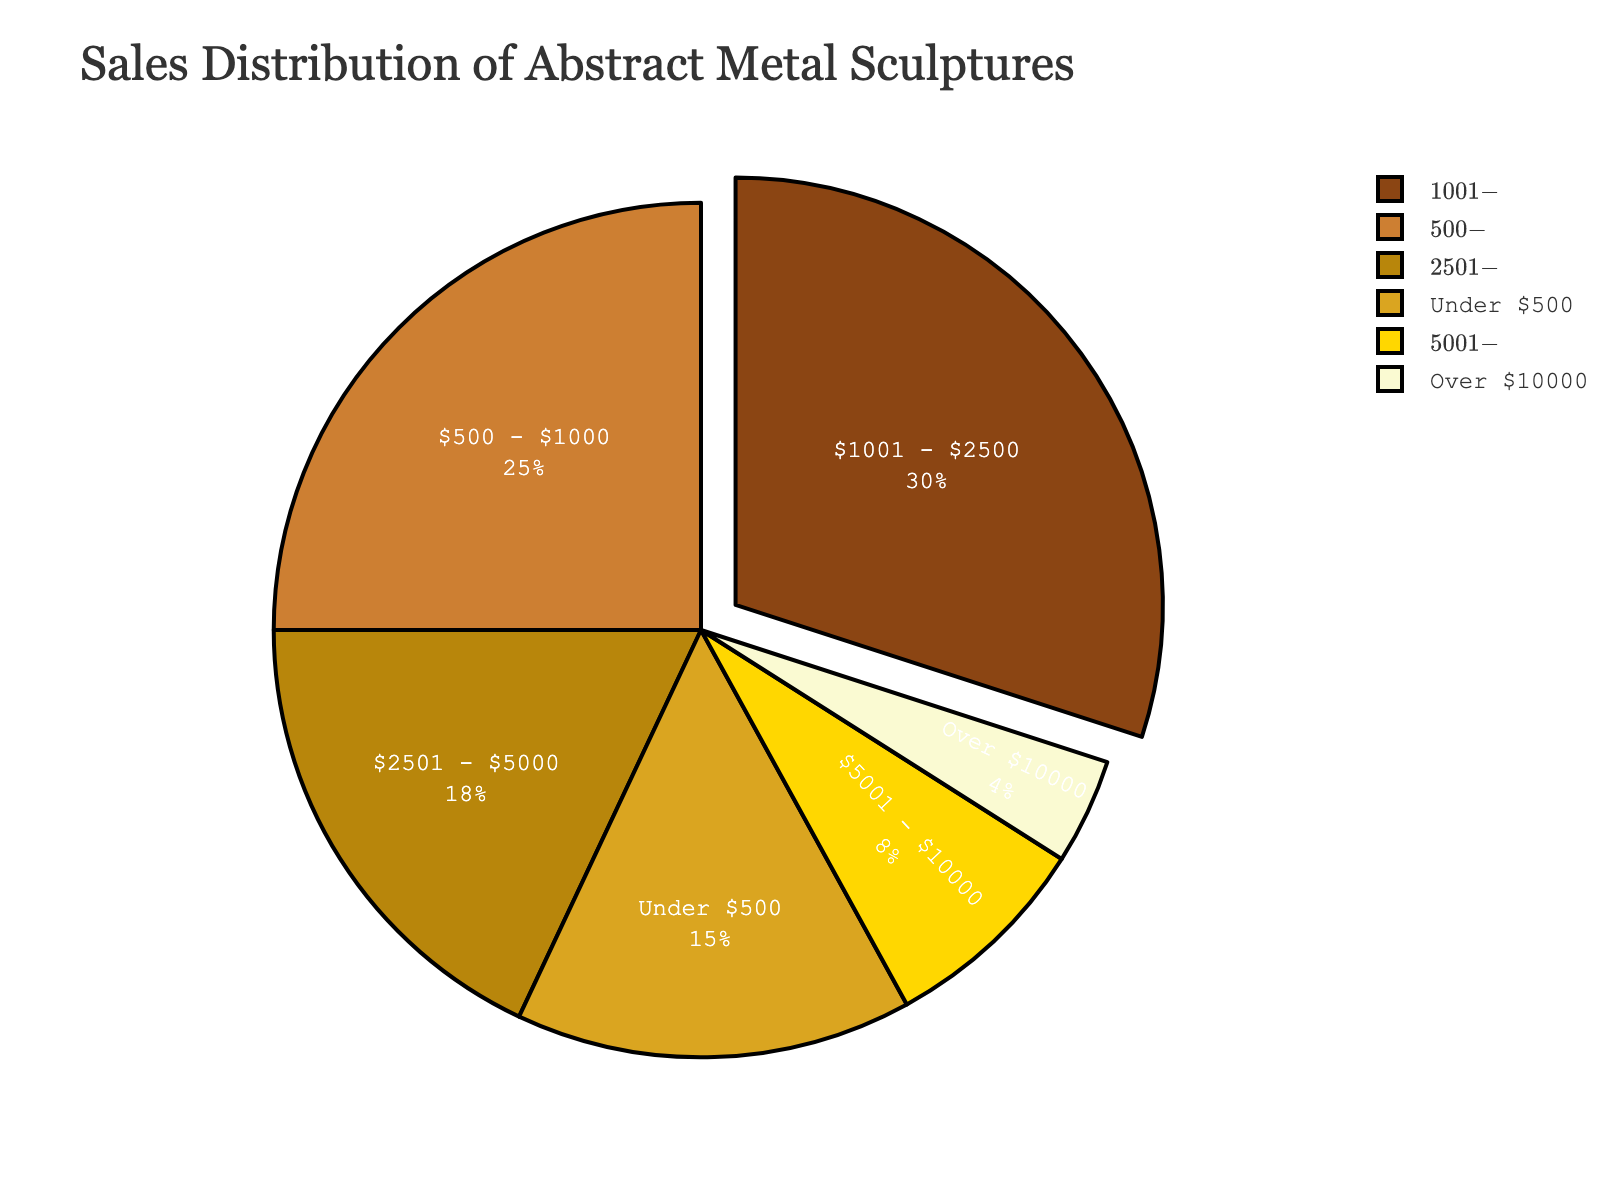Which price range has the largest sales percentage? The figure shows the distribution of sales percentages for different price ranges. The segment labeled '$1001 - $2500' has the largest slice, indicating it has the highest percentage.
Answer: $1001 - $2500 Which price range has the smallest sales percentage? By observing the pie chart, the segment labeled 'Over $10000' is the smallest, indicating it has the lowest sales percentage.
Answer: Over $10000 What is the combined percentage of sales for sculptures priced above $5000? The combined percentage for the '$5001 - $10000' and 'Over $10000' segments can be found by summing their percentages: $5001 - $10000 (8%) + Over $10000 (4%) = 12%.
Answer: 12% How much greater is the percentage of sales for sculptures priced $500 - $1000 compared to those over $10000? The percentage for '$500 - $1000' is 25%, and for 'Over $10000' is 4%. The difference is 25% - 4% = 21%.
Answer: 21% What is the average sales percentage for sculptures priced under $2500? First, identify the relevant segments: 'Under $500' (15%) and '$500 - $1000' (25%) and '$1001 - $2500' (30%). Sum these values and divide by the number of segments: (15% + 25% + 30%) / 3 = 70% / 3 ≈ 23.33%.
Answer: 23.33% Which price range is represented by a golden color in the pie chart? By interpreting the provided description of the custom color palette, the color 'golden' corresponds to the segment labeled '$2501 - $5000'.
Answer: $2501 - $5000 Do sculptures priced under $1000 account for more than 40% of sales? The relevant segments are 'Under $500' (15%) and '$500 - $1000' (25%). Summing these gives 15% + 25% = 40%.
Answer: No Which price range is closest to having the median sales percentage? To find the median, order the percentages: 4%, 8%, 15%, 18%, 25%, 30%. The middle values are 18% and 25%, with their average being (18% + 25%) / 2 = 21.5%. The closest segment is '$2501 - $5000' with 18% sales.
Answer: $2501 - $5000 What is the sales percentage for sculptures priced between $1001 and $5000? The relevant segments are '$1001 - $2500' (30%) and '$2501 - $5000' (18%). Summing these gives 30% + 18% = 48%.
Answer: 48% How does the percentage of sales for sculptures priced under $500 compare to those priced $5001 - $10000? The percentage for 'Under $500' is 15%, and for '$5001 - $10000' is 8%. Comparing these, 15% is greater than 8%.
Answer: Under $500 is greater 